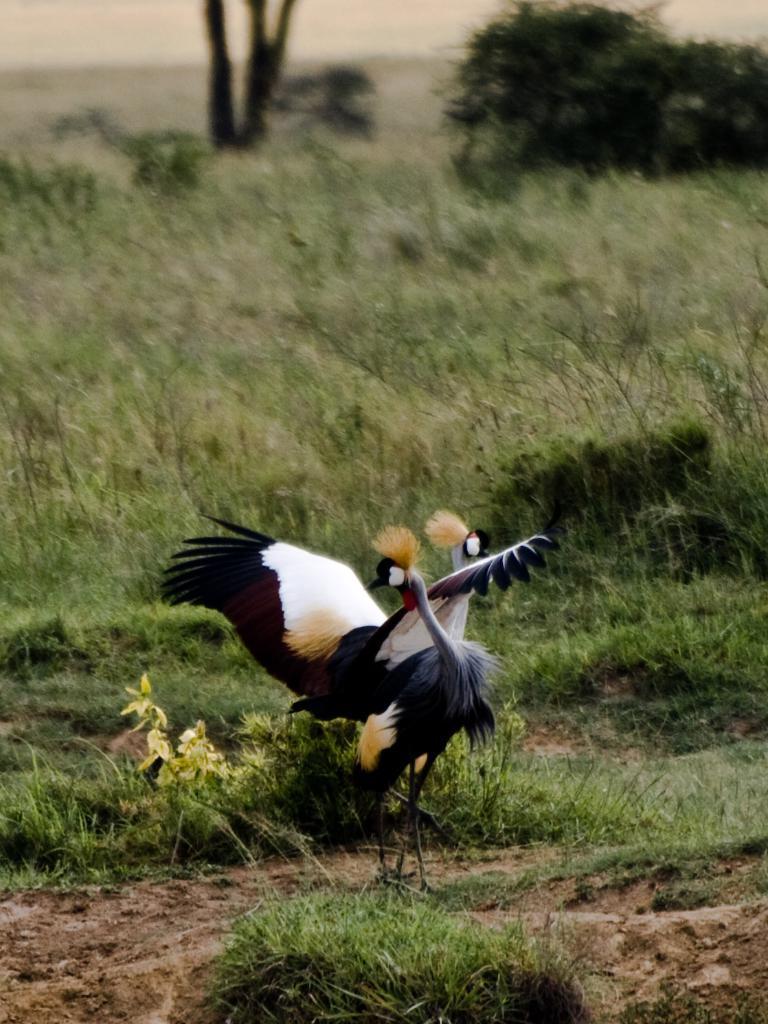How would you summarize this image in a sentence or two? In the center of the image, we can see birds and in the background, there are trees. At the bottom, there is ground covered with grass. 